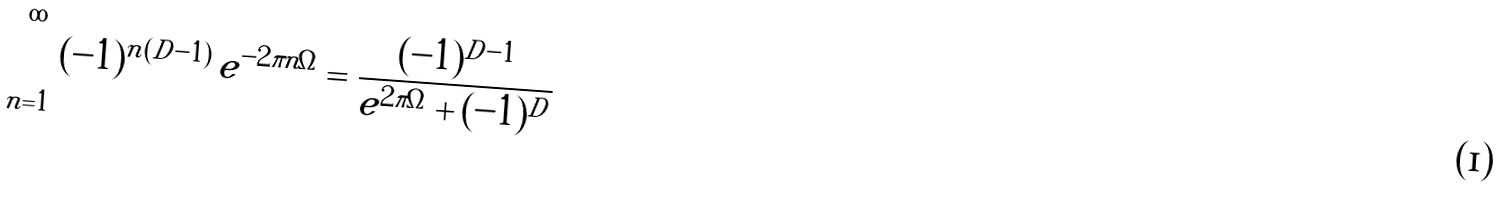<formula> <loc_0><loc_0><loc_500><loc_500>\sum _ { n = 1 } ^ { \infty } ( - 1 ) ^ { n ( D - 1 ) } \, e ^ { - 2 \pi n \Omega } = \frac { ( - 1 ) ^ { D - 1 } } { e ^ { 2 \pi \Omega } + ( - 1 ) ^ { D } }</formula> 